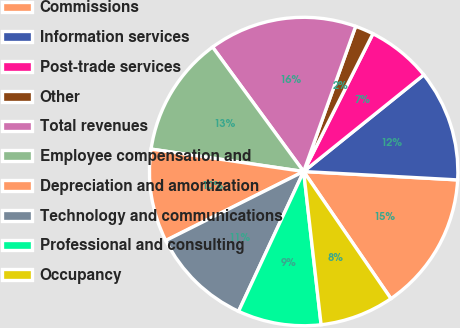<chart> <loc_0><loc_0><loc_500><loc_500><pie_chart><fcel>Commissions<fcel>Information services<fcel>Post-trade services<fcel>Other<fcel>Total revenues<fcel>Employee compensation and<fcel>Depreciation and amortization<fcel>Technology and communications<fcel>Professional and consulting<fcel>Occupancy<nl><fcel>14.56%<fcel>11.65%<fcel>6.8%<fcel>1.94%<fcel>15.53%<fcel>12.62%<fcel>9.71%<fcel>10.68%<fcel>8.74%<fcel>7.77%<nl></chart> 